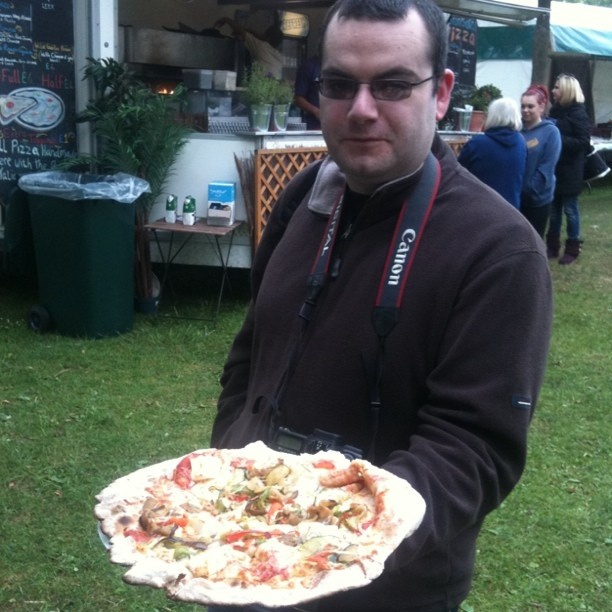Describe the objects in this image and their specific colors. I can see people in navy, black, gray, and darkgray tones, pizza in navy, ivory, tan, and darkgray tones, potted plant in navy, black, teal, gray, and darkgreen tones, people in navy, black, darkgray, and gray tones, and people in navy, black, lightgray, and darkgray tones in this image. 